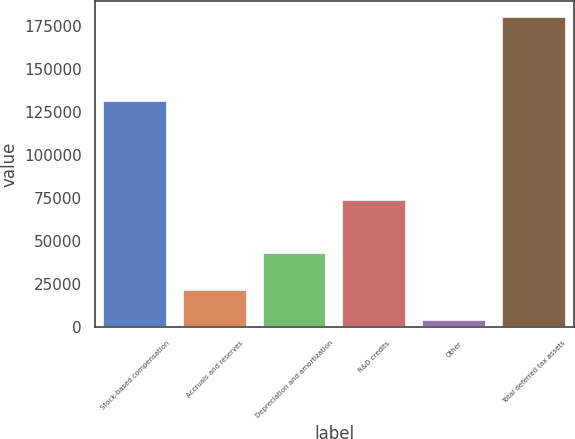<chart> <loc_0><loc_0><loc_500><loc_500><bar_chart><fcel>Stock-based compensation<fcel>Accruals and reserves<fcel>Depreciation and amortization<fcel>R&D credits<fcel>Other<fcel>Total deferred tax assets<nl><fcel>131339<fcel>21639.3<fcel>43204<fcel>74091<fcel>3980<fcel>180573<nl></chart> 